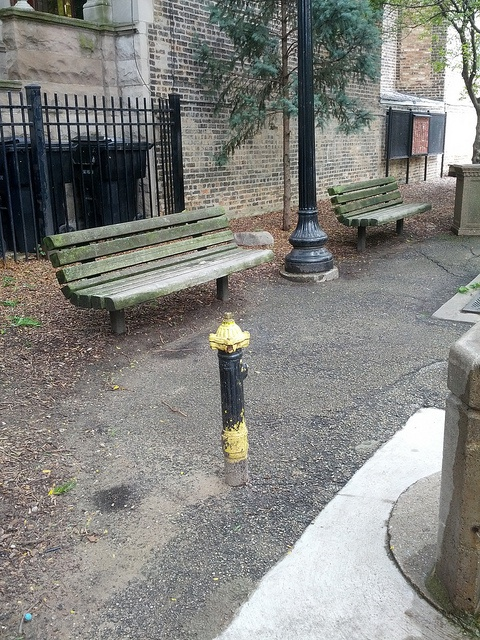Describe the objects in this image and their specific colors. I can see bench in darkgray, gray, black, and lightgray tones, fire hydrant in darkgray, gray, black, and khaki tones, and bench in darkgray, gray, and black tones in this image. 